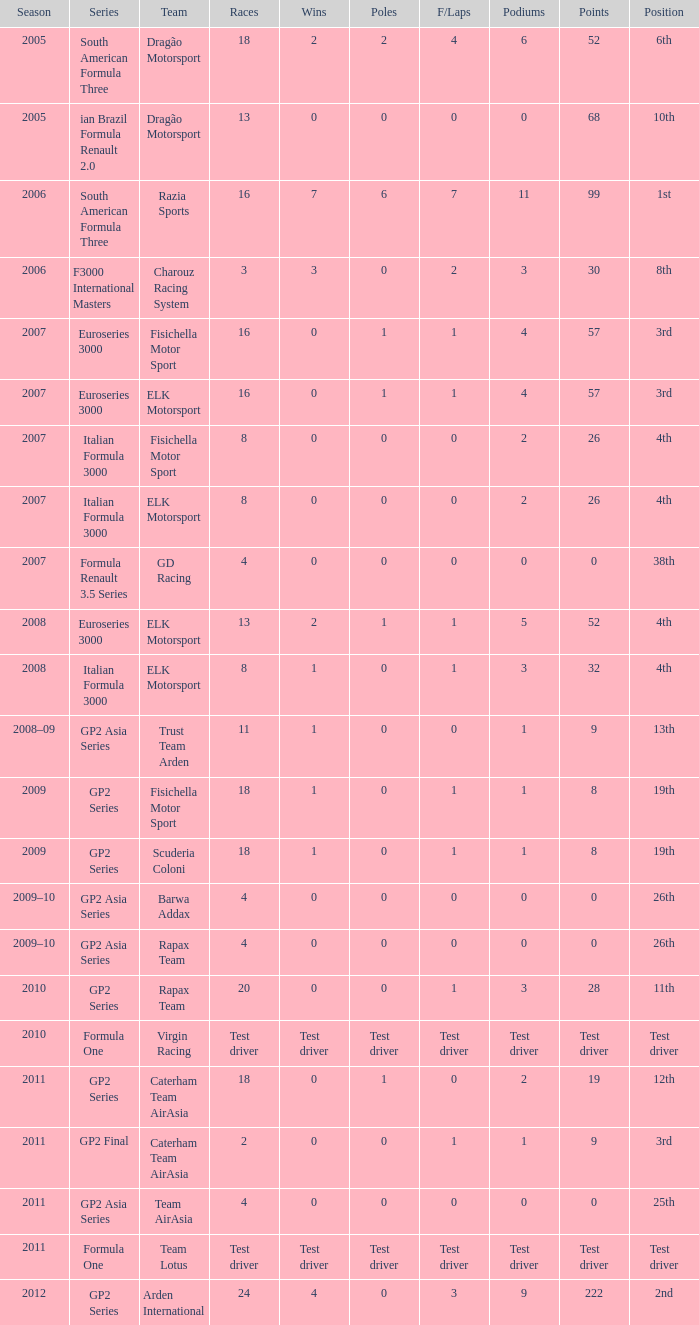How many races did he do in the year he had 8 points? 18, 18. 